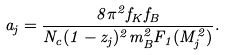<formula> <loc_0><loc_0><loc_500><loc_500>a _ { j } = \frac { 8 \pi ^ { 2 } f _ { K } f _ { B } } { N _ { c } ( 1 - z _ { j } ) ^ { 2 } m _ { B } ^ { 2 } F _ { 1 } ( M _ { j } ^ { 2 } ) } .</formula> 